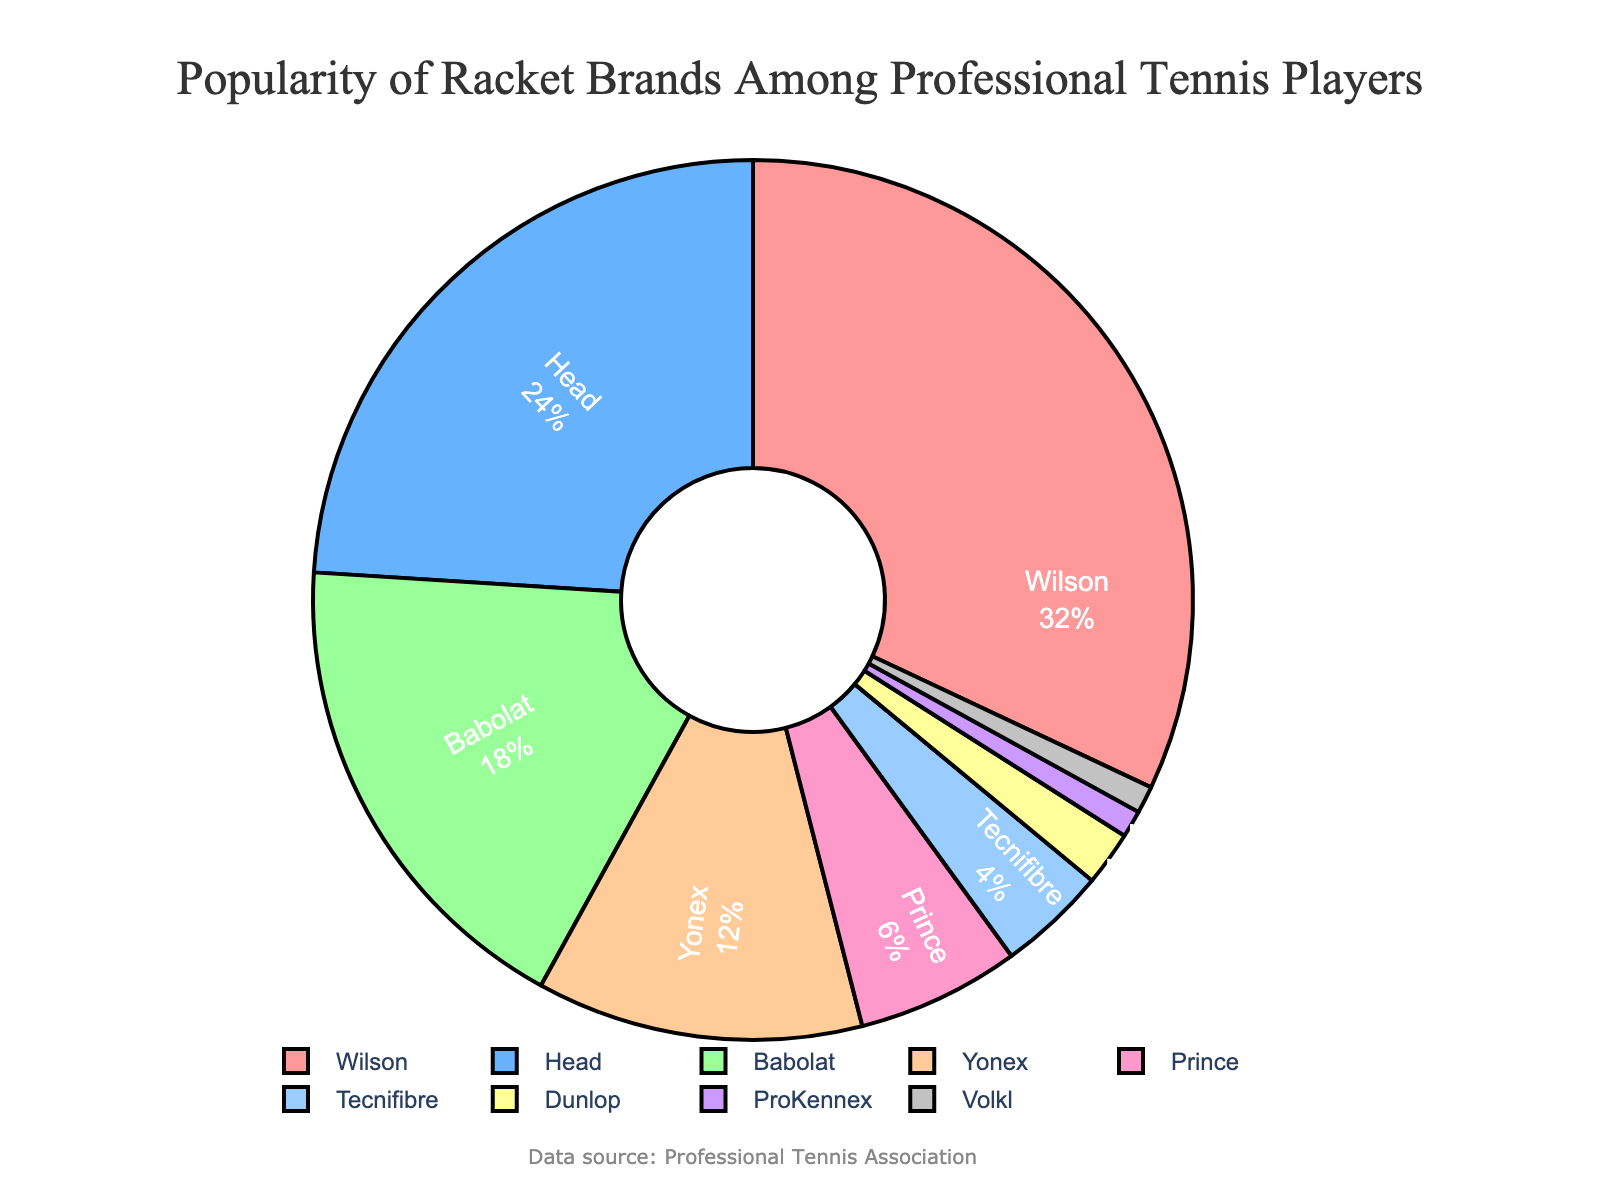What's the most popular racket brand among professional tennis players? The figure shows that Wilson holds the largest percentage slice of the pie chart.
Answer: Wilson Which two brands are least popular among professional tennis players? The smallest percentages in the pie chart are for ProKennex and Volkl, each having 1%.
Answer: ProKennex and Volkl What is the combined percentage of players using Wilson and Head rackets? Wilson has 32% and Head has 24%. Adding these percentages together gives 32% + 24% = 56%.
Answer: 56% How does the popularity of Babolat rackets compare to that of Yonex? The percentage for Babolat is 18%, and for Yonex, it is 12%. 18% is greater than 12%.
Answer: Babolat is more popular than Yonex Which brand has twice the popularity of Yonex rackets? Yonex has 12%. A brand with twice the popularity would have 12% * 2 = 24%. Head has exactly 24%.
Answer: Head What is the total percentage of players using Prince, Tecnifibre, and Dunlop rackets combined? Add the percentage of Prince (6%), Tecnifibre (4%), and Dunlop (2%). The total is 6% + 4% + 2% = 12%.
Answer: 12% Do the combined percentages of the three least popular brands exceed Yonex's percentage? The three least popular brands are Dunlop (2%), ProKennex (1%), and Volkl (1%). Their combined percentage is 2% + 1% + 1% = 4%. Yonex has 12%, which is greater than 4%.
Answer: No What can you infer about the market share of brands other than Wilson and Head? Adding the percentages of Wilson (32%) and Head (24%) gives 32% + 24% = 56%. Therefore, other brands hold 100% - 56% = 44% of the market share.
Answer: 44% 